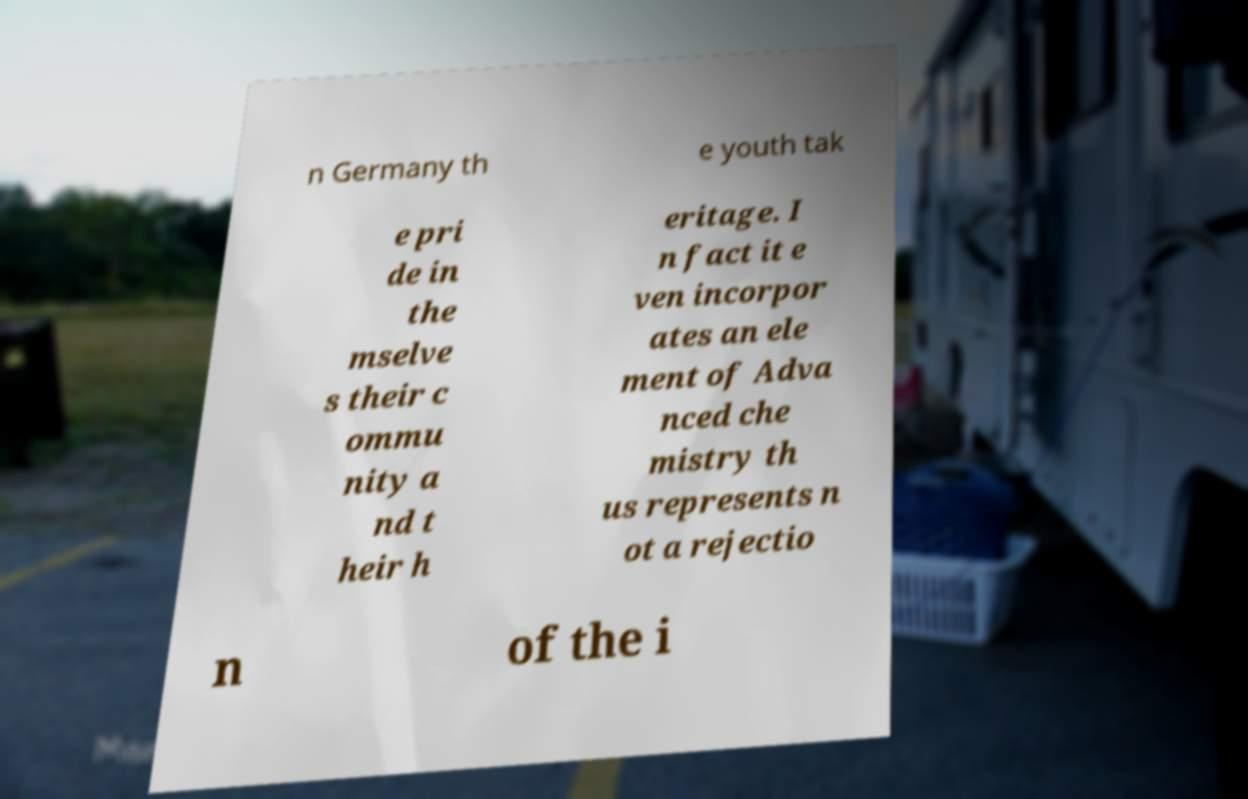I need the written content from this picture converted into text. Can you do that? n Germany th e youth tak e pri de in the mselve s their c ommu nity a nd t heir h eritage. I n fact it e ven incorpor ates an ele ment of Adva nced che mistry th us represents n ot a rejectio n of the i 